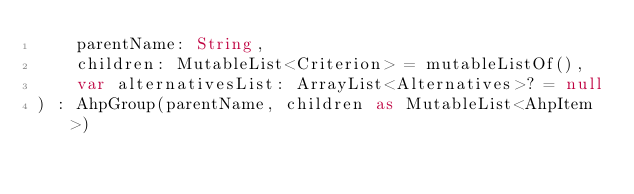<code> <loc_0><loc_0><loc_500><loc_500><_Kotlin_>    parentName: String,
    children: MutableList<Criterion> = mutableListOf(),
    var alternativesList: ArrayList<Alternatives>? = null
) : AhpGroup(parentName, children as MutableList<AhpItem>)</code> 